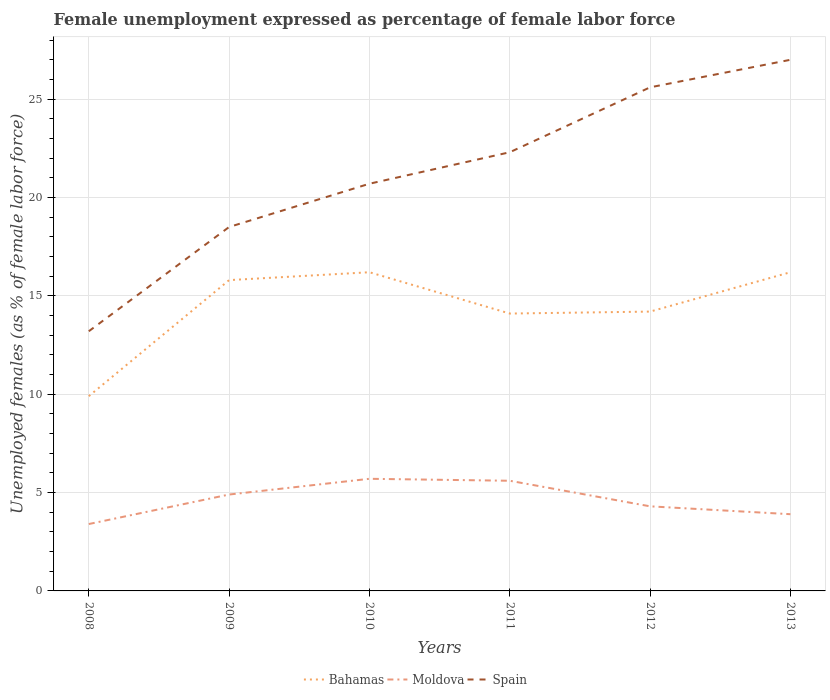Across all years, what is the maximum unemployment in females in in Bahamas?
Give a very brief answer. 9.9. In which year was the unemployment in females in in Bahamas maximum?
Ensure brevity in your answer.  2008. What is the total unemployment in females in in Spain in the graph?
Offer a very short reply. -3.3. What is the difference between the highest and the second highest unemployment in females in in Bahamas?
Provide a short and direct response. 6.3. What is the difference between the highest and the lowest unemployment in females in in Moldova?
Provide a succinct answer. 3. How many lines are there?
Provide a succinct answer. 3. How many years are there in the graph?
Offer a terse response. 6. Are the values on the major ticks of Y-axis written in scientific E-notation?
Give a very brief answer. No. Does the graph contain any zero values?
Give a very brief answer. No. How many legend labels are there?
Offer a very short reply. 3. What is the title of the graph?
Your answer should be compact. Female unemployment expressed as percentage of female labor force. Does "Dominica" appear as one of the legend labels in the graph?
Ensure brevity in your answer.  No. What is the label or title of the X-axis?
Make the answer very short. Years. What is the label or title of the Y-axis?
Provide a short and direct response. Unemployed females (as % of female labor force). What is the Unemployed females (as % of female labor force) in Bahamas in 2008?
Your response must be concise. 9.9. What is the Unemployed females (as % of female labor force) in Moldova in 2008?
Make the answer very short. 3.4. What is the Unemployed females (as % of female labor force) in Spain in 2008?
Your answer should be very brief. 13.2. What is the Unemployed females (as % of female labor force) of Bahamas in 2009?
Your response must be concise. 15.8. What is the Unemployed females (as % of female labor force) of Moldova in 2009?
Your response must be concise. 4.9. What is the Unemployed females (as % of female labor force) of Spain in 2009?
Ensure brevity in your answer.  18.5. What is the Unemployed females (as % of female labor force) of Bahamas in 2010?
Ensure brevity in your answer.  16.2. What is the Unemployed females (as % of female labor force) of Moldova in 2010?
Make the answer very short. 5.7. What is the Unemployed females (as % of female labor force) of Spain in 2010?
Ensure brevity in your answer.  20.7. What is the Unemployed females (as % of female labor force) of Bahamas in 2011?
Your answer should be compact. 14.1. What is the Unemployed females (as % of female labor force) of Moldova in 2011?
Your response must be concise. 5.6. What is the Unemployed females (as % of female labor force) of Spain in 2011?
Offer a terse response. 22.3. What is the Unemployed females (as % of female labor force) in Bahamas in 2012?
Ensure brevity in your answer.  14.2. What is the Unemployed females (as % of female labor force) of Moldova in 2012?
Your response must be concise. 4.3. What is the Unemployed females (as % of female labor force) of Spain in 2012?
Offer a terse response. 25.6. What is the Unemployed females (as % of female labor force) in Bahamas in 2013?
Offer a very short reply. 16.2. What is the Unemployed females (as % of female labor force) in Moldova in 2013?
Your answer should be compact. 3.9. What is the Unemployed females (as % of female labor force) in Spain in 2013?
Keep it short and to the point. 27. Across all years, what is the maximum Unemployed females (as % of female labor force) in Bahamas?
Provide a short and direct response. 16.2. Across all years, what is the maximum Unemployed females (as % of female labor force) of Moldova?
Provide a short and direct response. 5.7. Across all years, what is the minimum Unemployed females (as % of female labor force) of Bahamas?
Your answer should be very brief. 9.9. Across all years, what is the minimum Unemployed females (as % of female labor force) of Moldova?
Ensure brevity in your answer.  3.4. Across all years, what is the minimum Unemployed females (as % of female labor force) in Spain?
Your response must be concise. 13.2. What is the total Unemployed females (as % of female labor force) of Bahamas in the graph?
Provide a succinct answer. 86.4. What is the total Unemployed females (as % of female labor force) in Moldova in the graph?
Offer a very short reply. 27.8. What is the total Unemployed females (as % of female labor force) of Spain in the graph?
Your response must be concise. 127.3. What is the difference between the Unemployed females (as % of female labor force) of Spain in 2008 and that in 2009?
Your answer should be compact. -5.3. What is the difference between the Unemployed females (as % of female labor force) in Spain in 2008 and that in 2010?
Offer a very short reply. -7.5. What is the difference between the Unemployed females (as % of female labor force) of Moldova in 2008 and that in 2011?
Your answer should be compact. -2.2. What is the difference between the Unemployed females (as % of female labor force) of Moldova in 2008 and that in 2013?
Make the answer very short. -0.5. What is the difference between the Unemployed females (as % of female labor force) of Spain in 2009 and that in 2010?
Your response must be concise. -2.2. What is the difference between the Unemployed females (as % of female labor force) in Bahamas in 2009 and that in 2011?
Provide a succinct answer. 1.7. What is the difference between the Unemployed females (as % of female labor force) in Spain in 2009 and that in 2011?
Ensure brevity in your answer.  -3.8. What is the difference between the Unemployed females (as % of female labor force) in Moldova in 2009 and that in 2012?
Provide a succinct answer. 0.6. What is the difference between the Unemployed females (as % of female labor force) in Spain in 2009 and that in 2012?
Keep it short and to the point. -7.1. What is the difference between the Unemployed females (as % of female labor force) of Bahamas in 2010 and that in 2012?
Make the answer very short. 2. What is the difference between the Unemployed females (as % of female labor force) in Spain in 2010 and that in 2012?
Provide a succinct answer. -4.9. What is the difference between the Unemployed females (as % of female labor force) in Moldova in 2010 and that in 2013?
Keep it short and to the point. 1.8. What is the difference between the Unemployed females (as % of female labor force) in Spain in 2011 and that in 2012?
Ensure brevity in your answer.  -3.3. What is the difference between the Unemployed females (as % of female labor force) in Bahamas in 2011 and that in 2013?
Ensure brevity in your answer.  -2.1. What is the difference between the Unemployed females (as % of female labor force) of Moldova in 2011 and that in 2013?
Give a very brief answer. 1.7. What is the difference between the Unemployed females (as % of female labor force) of Spain in 2011 and that in 2013?
Ensure brevity in your answer.  -4.7. What is the difference between the Unemployed females (as % of female labor force) in Spain in 2012 and that in 2013?
Ensure brevity in your answer.  -1.4. What is the difference between the Unemployed females (as % of female labor force) in Bahamas in 2008 and the Unemployed females (as % of female labor force) in Moldova in 2009?
Keep it short and to the point. 5. What is the difference between the Unemployed females (as % of female labor force) in Moldova in 2008 and the Unemployed females (as % of female labor force) in Spain in 2009?
Your answer should be very brief. -15.1. What is the difference between the Unemployed females (as % of female labor force) in Bahamas in 2008 and the Unemployed females (as % of female labor force) in Moldova in 2010?
Your answer should be very brief. 4.2. What is the difference between the Unemployed females (as % of female labor force) of Moldova in 2008 and the Unemployed females (as % of female labor force) of Spain in 2010?
Ensure brevity in your answer.  -17.3. What is the difference between the Unemployed females (as % of female labor force) of Moldova in 2008 and the Unemployed females (as % of female labor force) of Spain in 2011?
Ensure brevity in your answer.  -18.9. What is the difference between the Unemployed females (as % of female labor force) in Bahamas in 2008 and the Unemployed females (as % of female labor force) in Moldova in 2012?
Provide a succinct answer. 5.6. What is the difference between the Unemployed females (as % of female labor force) of Bahamas in 2008 and the Unemployed females (as % of female labor force) of Spain in 2012?
Your answer should be very brief. -15.7. What is the difference between the Unemployed females (as % of female labor force) in Moldova in 2008 and the Unemployed females (as % of female labor force) in Spain in 2012?
Your answer should be very brief. -22.2. What is the difference between the Unemployed females (as % of female labor force) of Bahamas in 2008 and the Unemployed females (as % of female labor force) of Moldova in 2013?
Your response must be concise. 6. What is the difference between the Unemployed females (as % of female labor force) in Bahamas in 2008 and the Unemployed females (as % of female labor force) in Spain in 2013?
Your answer should be very brief. -17.1. What is the difference between the Unemployed females (as % of female labor force) in Moldova in 2008 and the Unemployed females (as % of female labor force) in Spain in 2013?
Your response must be concise. -23.6. What is the difference between the Unemployed females (as % of female labor force) of Bahamas in 2009 and the Unemployed females (as % of female labor force) of Spain in 2010?
Keep it short and to the point. -4.9. What is the difference between the Unemployed females (as % of female labor force) in Moldova in 2009 and the Unemployed females (as % of female labor force) in Spain in 2010?
Make the answer very short. -15.8. What is the difference between the Unemployed females (as % of female labor force) in Bahamas in 2009 and the Unemployed females (as % of female labor force) in Spain in 2011?
Provide a short and direct response. -6.5. What is the difference between the Unemployed females (as % of female labor force) of Moldova in 2009 and the Unemployed females (as % of female labor force) of Spain in 2011?
Your response must be concise. -17.4. What is the difference between the Unemployed females (as % of female labor force) in Bahamas in 2009 and the Unemployed females (as % of female labor force) in Moldova in 2012?
Your answer should be very brief. 11.5. What is the difference between the Unemployed females (as % of female labor force) in Moldova in 2009 and the Unemployed females (as % of female labor force) in Spain in 2012?
Offer a terse response. -20.7. What is the difference between the Unemployed females (as % of female labor force) in Bahamas in 2009 and the Unemployed females (as % of female labor force) in Spain in 2013?
Ensure brevity in your answer.  -11.2. What is the difference between the Unemployed females (as % of female labor force) of Moldova in 2009 and the Unemployed females (as % of female labor force) of Spain in 2013?
Your answer should be very brief. -22.1. What is the difference between the Unemployed females (as % of female labor force) in Bahamas in 2010 and the Unemployed females (as % of female labor force) in Moldova in 2011?
Keep it short and to the point. 10.6. What is the difference between the Unemployed females (as % of female labor force) in Bahamas in 2010 and the Unemployed females (as % of female labor force) in Spain in 2011?
Your answer should be very brief. -6.1. What is the difference between the Unemployed females (as % of female labor force) of Moldova in 2010 and the Unemployed females (as % of female labor force) of Spain in 2011?
Offer a very short reply. -16.6. What is the difference between the Unemployed females (as % of female labor force) in Moldova in 2010 and the Unemployed females (as % of female labor force) in Spain in 2012?
Provide a short and direct response. -19.9. What is the difference between the Unemployed females (as % of female labor force) in Bahamas in 2010 and the Unemployed females (as % of female labor force) in Moldova in 2013?
Offer a very short reply. 12.3. What is the difference between the Unemployed females (as % of female labor force) of Bahamas in 2010 and the Unemployed females (as % of female labor force) of Spain in 2013?
Your answer should be compact. -10.8. What is the difference between the Unemployed females (as % of female labor force) of Moldova in 2010 and the Unemployed females (as % of female labor force) of Spain in 2013?
Offer a terse response. -21.3. What is the difference between the Unemployed females (as % of female labor force) of Moldova in 2011 and the Unemployed females (as % of female labor force) of Spain in 2012?
Your response must be concise. -20. What is the difference between the Unemployed females (as % of female labor force) of Bahamas in 2011 and the Unemployed females (as % of female labor force) of Moldova in 2013?
Give a very brief answer. 10.2. What is the difference between the Unemployed females (as % of female labor force) in Bahamas in 2011 and the Unemployed females (as % of female labor force) in Spain in 2013?
Your answer should be very brief. -12.9. What is the difference between the Unemployed females (as % of female labor force) of Moldova in 2011 and the Unemployed females (as % of female labor force) of Spain in 2013?
Your answer should be compact. -21.4. What is the difference between the Unemployed females (as % of female labor force) in Bahamas in 2012 and the Unemployed females (as % of female labor force) in Moldova in 2013?
Keep it short and to the point. 10.3. What is the difference between the Unemployed females (as % of female labor force) of Moldova in 2012 and the Unemployed females (as % of female labor force) of Spain in 2013?
Offer a very short reply. -22.7. What is the average Unemployed females (as % of female labor force) of Bahamas per year?
Ensure brevity in your answer.  14.4. What is the average Unemployed females (as % of female labor force) in Moldova per year?
Your answer should be compact. 4.63. What is the average Unemployed females (as % of female labor force) of Spain per year?
Your response must be concise. 21.22. In the year 2008, what is the difference between the Unemployed females (as % of female labor force) of Bahamas and Unemployed females (as % of female labor force) of Moldova?
Provide a short and direct response. 6.5. In the year 2009, what is the difference between the Unemployed females (as % of female labor force) in Bahamas and Unemployed females (as % of female labor force) in Spain?
Your answer should be compact. -2.7. In the year 2009, what is the difference between the Unemployed females (as % of female labor force) in Moldova and Unemployed females (as % of female labor force) in Spain?
Your answer should be compact. -13.6. In the year 2010, what is the difference between the Unemployed females (as % of female labor force) of Bahamas and Unemployed females (as % of female labor force) of Moldova?
Keep it short and to the point. 10.5. In the year 2010, what is the difference between the Unemployed females (as % of female labor force) of Bahamas and Unemployed females (as % of female labor force) of Spain?
Offer a very short reply. -4.5. In the year 2010, what is the difference between the Unemployed females (as % of female labor force) in Moldova and Unemployed females (as % of female labor force) in Spain?
Your answer should be compact. -15. In the year 2011, what is the difference between the Unemployed females (as % of female labor force) in Bahamas and Unemployed females (as % of female labor force) in Spain?
Provide a short and direct response. -8.2. In the year 2011, what is the difference between the Unemployed females (as % of female labor force) of Moldova and Unemployed females (as % of female labor force) of Spain?
Your answer should be very brief. -16.7. In the year 2012, what is the difference between the Unemployed females (as % of female labor force) in Bahamas and Unemployed females (as % of female labor force) in Spain?
Offer a very short reply. -11.4. In the year 2012, what is the difference between the Unemployed females (as % of female labor force) in Moldova and Unemployed females (as % of female labor force) in Spain?
Offer a terse response. -21.3. In the year 2013, what is the difference between the Unemployed females (as % of female labor force) of Moldova and Unemployed females (as % of female labor force) of Spain?
Provide a short and direct response. -23.1. What is the ratio of the Unemployed females (as % of female labor force) in Bahamas in 2008 to that in 2009?
Give a very brief answer. 0.63. What is the ratio of the Unemployed females (as % of female labor force) in Moldova in 2008 to that in 2009?
Your response must be concise. 0.69. What is the ratio of the Unemployed females (as % of female labor force) in Spain in 2008 to that in 2009?
Your answer should be compact. 0.71. What is the ratio of the Unemployed females (as % of female labor force) of Bahamas in 2008 to that in 2010?
Make the answer very short. 0.61. What is the ratio of the Unemployed females (as % of female labor force) in Moldova in 2008 to that in 2010?
Offer a terse response. 0.6. What is the ratio of the Unemployed females (as % of female labor force) of Spain in 2008 to that in 2010?
Provide a short and direct response. 0.64. What is the ratio of the Unemployed females (as % of female labor force) in Bahamas in 2008 to that in 2011?
Your response must be concise. 0.7. What is the ratio of the Unemployed females (as % of female labor force) of Moldova in 2008 to that in 2011?
Make the answer very short. 0.61. What is the ratio of the Unemployed females (as % of female labor force) in Spain in 2008 to that in 2011?
Keep it short and to the point. 0.59. What is the ratio of the Unemployed females (as % of female labor force) of Bahamas in 2008 to that in 2012?
Ensure brevity in your answer.  0.7. What is the ratio of the Unemployed females (as % of female labor force) of Moldova in 2008 to that in 2012?
Make the answer very short. 0.79. What is the ratio of the Unemployed females (as % of female labor force) in Spain in 2008 to that in 2012?
Offer a terse response. 0.52. What is the ratio of the Unemployed females (as % of female labor force) in Bahamas in 2008 to that in 2013?
Provide a short and direct response. 0.61. What is the ratio of the Unemployed females (as % of female labor force) in Moldova in 2008 to that in 2013?
Your response must be concise. 0.87. What is the ratio of the Unemployed females (as % of female labor force) of Spain in 2008 to that in 2013?
Your answer should be compact. 0.49. What is the ratio of the Unemployed females (as % of female labor force) of Bahamas in 2009 to that in 2010?
Your response must be concise. 0.98. What is the ratio of the Unemployed females (as % of female labor force) in Moldova in 2009 to that in 2010?
Provide a succinct answer. 0.86. What is the ratio of the Unemployed females (as % of female labor force) in Spain in 2009 to that in 2010?
Provide a succinct answer. 0.89. What is the ratio of the Unemployed females (as % of female labor force) of Bahamas in 2009 to that in 2011?
Keep it short and to the point. 1.12. What is the ratio of the Unemployed females (as % of female labor force) in Moldova in 2009 to that in 2011?
Ensure brevity in your answer.  0.88. What is the ratio of the Unemployed females (as % of female labor force) of Spain in 2009 to that in 2011?
Your response must be concise. 0.83. What is the ratio of the Unemployed females (as % of female labor force) of Bahamas in 2009 to that in 2012?
Offer a terse response. 1.11. What is the ratio of the Unemployed females (as % of female labor force) of Moldova in 2009 to that in 2012?
Give a very brief answer. 1.14. What is the ratio of the Unemployed females (as % of female labor force) of Spain in 2009 to that in 2012?
Make the answer very short. 0.72. What is the ratio of the Unemployed females (as % of female labor force) of Bahamas in 2009 to that in 2013?
Give a very brief answer. 0.98. What is the ratio of the Unemployed females (as % of female labor force) in Moldova in 2009 to that in 2013?
Provide a short and direct response. 1.26. What is the ratio of the Unemployed females (as % of female labor force) in Spain in 2009 to that in 2013?
Your response must be concise. 0.69. What is the ratio of the Unemployed females (as % of female labor force) of Bahamas in 2010 to that in 2011?
Offer a very short reply. 1.15. What is the ratio of the Unemployed females (as % of female labor force) of Moldova in 2010 to that in 2011?
Give a very brief answer. 1.02. What is the ratio of the Unemployed females (as % of female labor force) in Spain in 2010 to that in 2011?
Make the answer very short. 0.93. What is the ratio of the Unemployed females (as % of female labor force) in Bahamas in 2010 to that in 2012?
Your response must be concise. 1.14. What is the ratio of the Unemployed females (as % of female labor force) in Moldova in 2010 to that in 2012?
Provide a succinct answer. 1.33. What is the ratio of the Unemployed females (as % of female labor force) of Spain in 2010 to that in 2012?
Your answer should be very brief. 0.81. What is the ratio of the Unemployed females (as % of female labor force) of Moldova in 2010 to that in 2013?
Your answer should be compact. 1.46. What is the ratio of the Unemployed females (as % of female labor force) of Spain in 2010 to that in 2013?
Your response must be concise. 0.77. What is the ratio of the Unemployed females (as % of female labor force) of Moldova in 2011 to that in 2012?
Give a very brief answer. 1.3. What is the ratio of the Unemployed females (as % of female labor force) of Spain in 2011 to that in 2012?
Provide a short and direct response. 0.87. What is the ratio of the Unemployed females (as % of female labor force) in Bahamas in 2011 to that in 2013?
Keep it short and to the point. 0.87. What is the ratio of the Unemployed females (as % of female labor force) of Moldova in 2011 to that in 2013?
Offer a very short reply. 1.44. What is the ratio of the Unemployed females (as % of female labor force) of Spain in 2011 to that in 2013?
Make the answer very short. 0.83. What is the ratio of the Unemployed females (as % of female labor force) in Bahamas in 2012 to that in 2013?
Your response must be concise. 0.88. What is the ratio of the Unemployed females (as % of female labor force) of Moldova in 2012 to that in 2013?
Provide a succinct answer. 1.1. What is the ratio of the Unemployed females (as % of female labor force) in Spain in 2012 to that in 2013?
Offer a very short reply. 0.95. What is the difference between the highest and the second highest Unemployed females (as % of female labor force) of Moldova?
Provide a short and direct response. 0.1. What is the difference between the highest and the second highest Unemployed females (as % of female labor force) of Spain?
Keep it short and to the point. 1.4. What is the difference between the highest and the lowest Unemployed females (as % of female labor force) of Moldova?
Keep it short and to the point. 2.3. What is the difference between the highest and the lowest Unemployed females (as % of female labor force) in Spain?
Offer a terse response. 13.8. 